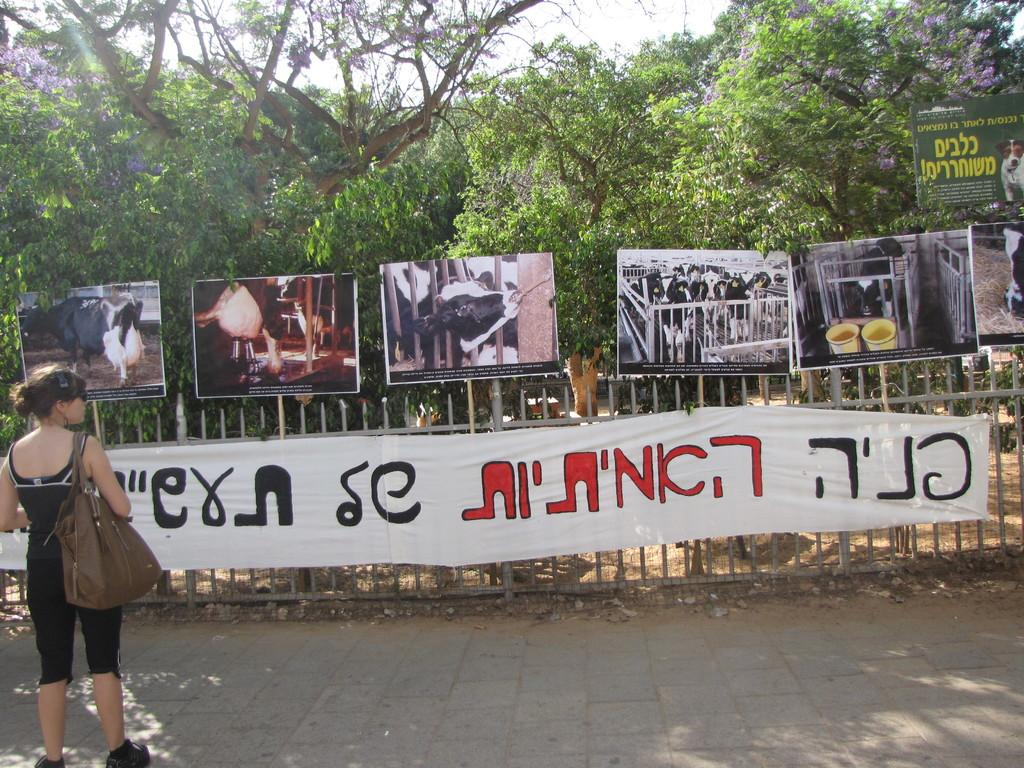What is the main subject of the image? There is a woman standing in the image. What type of architectural feature can be seen in the image? There are iron grilles in the image. What other objects are present in the image? There are boards and a banner in the image. What type of natural elements can be seen in the image? There are trees in the image. What is visible in the background of the image? The sky is visible in the background of the image. What type of pump is being used to water the trees in the image? There is no pump visible in the image, and the trees do not appear to be receiving any water. Is the woman wearing a veil in the image? There is no indication of a veil in the image; the woman's clothing is not described. 